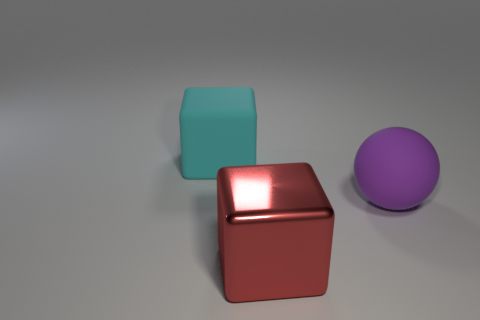The thing that is both left of the large purple sphere and behind the big red thing is made of what material?
Your response must be concise. Rubber. There is a purple ball that is the same size as the shiny thing; what is it made of?
Offer a terse response. Rubber. What size is the purple ball that is the same material as the cyan thing?
Ensure brevity in your answer.  Large. The big matte object in front of the big cyan cube has what shape?
Your response must be concise. Sphere. Are there any cyan things behind the large red metal thing that is right of the rubber cube that is on the left side of the red metal thing?
Your answer should be very brief. Yes. There is another cyan object that is the same shape as the metal object; what material is it?
Your answer should be compact. Rubber. Is there any other thing that has the same material as the big red block?
Your response must be concise. No. How many blocks are either large matte objects or cyan matte objects?
Ensure brevity in your answer.  1. There is a object that is behind the rubber thing that is on the right side of the large cyan matte thing; what is its material?
Offer a terse response. Rubber. Is the number of red cubes that are on the right side of the red metal cube less than the number of red objects?
Your response must be concise. Yes. 